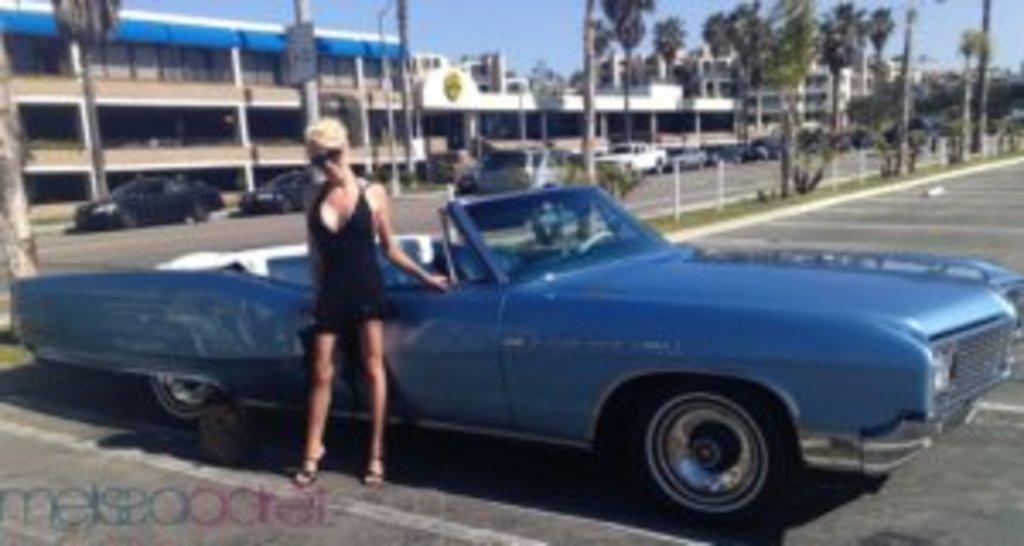How would you summarize this image in a sentence or two? This image is taken outdoors. At the top of the image there is a sky. At the bottom of the image there is a road. In the middle of the image a car is parked on the road and a woman is standing on the road. In the background there are many buildings, trees and poles. A few cars are parked on the road. 